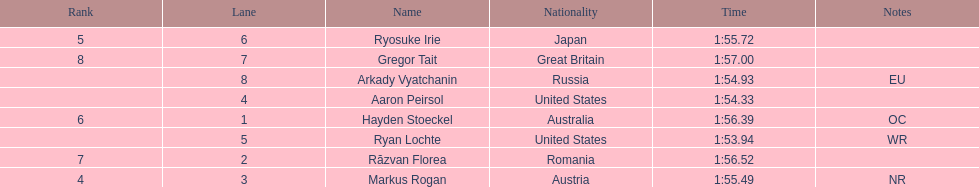How many swimmers were from the us? 2. 